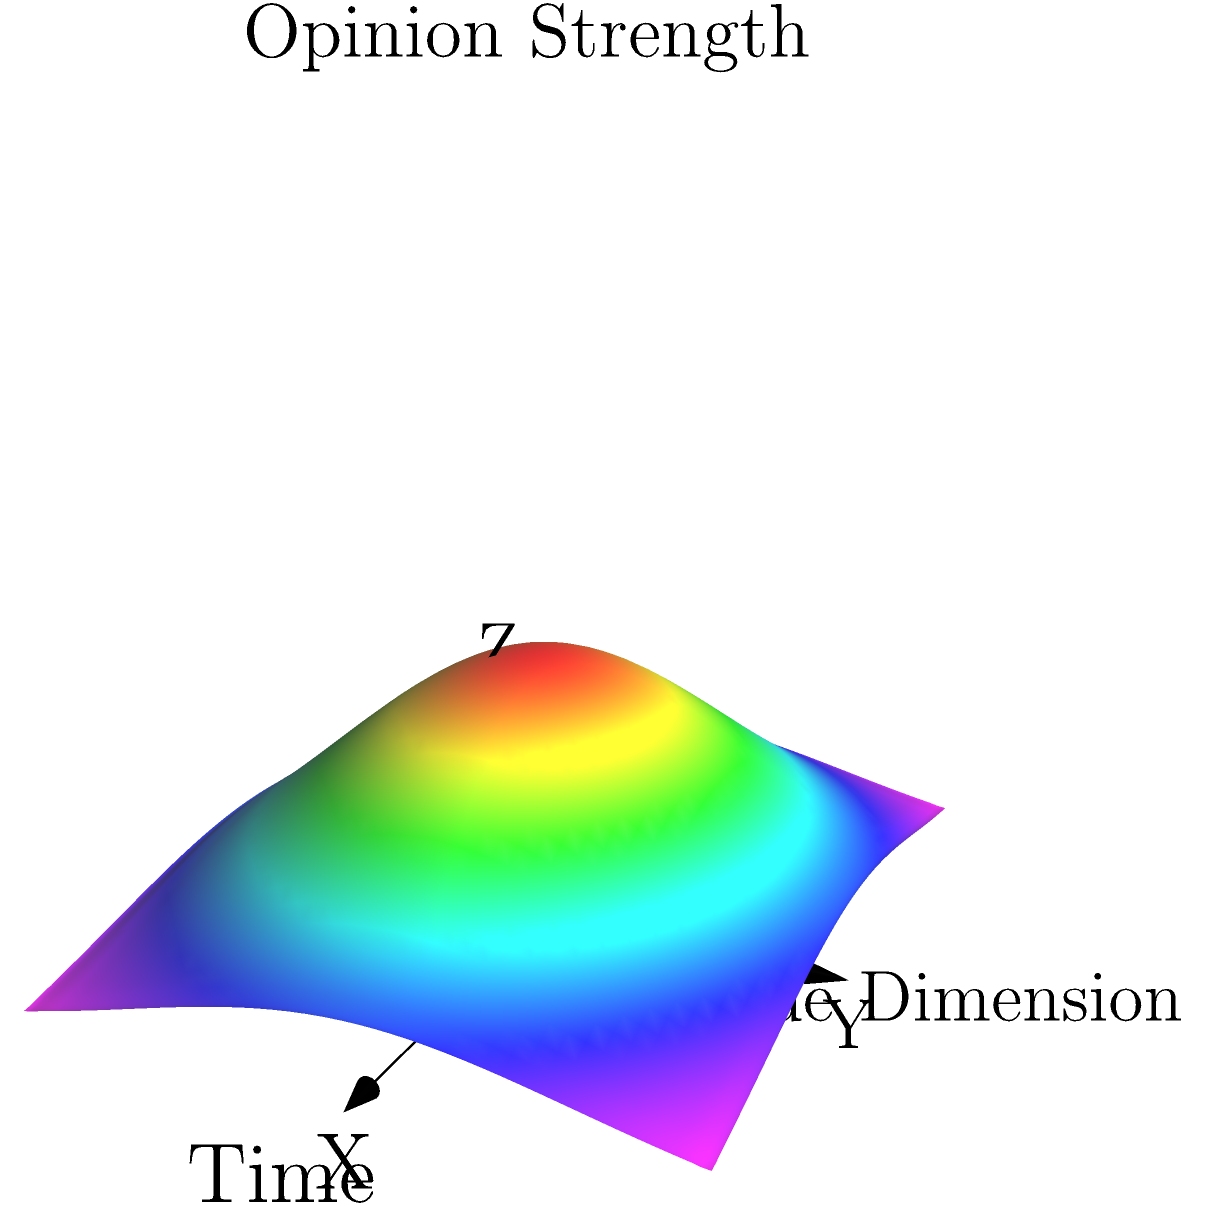Consider the three-dimensional representation of public opinion shifts over time shown in the figure. The X-axis represents time, the Y-axis represents different issue dimensions, and the Z-axis represents the strength of public opinion. The surface shows a Gaussian-like distribution that narrows and increases in height over time. What topological property does this surface exhibit, and how might it relate to the concentration of public opinion during a specific period of the Cold War? To answer this question, let's analyze the surface and its topological properties step-by-step:

1. Surface shape: The surface shows a Gaussian-like distribution in the XY plane, with a peak in the center.

2. Time evolution: As we move along the X-axis (time), the surface becomes narrower and taller.

3. Topological property: This surface exhibits a property called "homotopy". The surface at any given time slice (Y-Z plane) is homotopic to every other time slice, meaning it can be continuously deformed from one shape to another without tearing or gluing.

4. Interpretation in context:
   a) The narrowing of the surface over time represents a concentration of public opinion.
   b) The increasing height indicates stronger overall opinions.
   c) The maintenance of the basic shape (homotopy) suggests a consistent underlying structure of public opinion.

5. Relation to the Cold War:
   This topological representation could model the concentration of public opinion during a specific Cold War event, such as the Cuban Missile Crisis. As the crisis unfolded:
   a) Public attention would focus on a narrower range of issues (narrowing surface).
   b) Opinions would likely become stronger (increasing height).
   c) The basic structure of opinion distribution would remain similar (homotopy).

6. Mathematical representation:
   The surface could be described by a function like:
   $$f(x,y,z) = A(x) \cdot e^{-\frac{y^2}{2\sigma(x)^2}}$$
   where $A(x)$ increases with $x$ (time) and $\sigma(x)$ decreases with $x$, representing the narrowing and heightening of the distribution.

This topological approach allows for a geometric understanding of how public opinion evolved during critical periods of the Cold War, highlighting the concentration of attention and intensification of views while maintaining a consistent underlying structure.
Answer: Homotopy, representing concentration and intensification of public opinion while maintaining consistent structure. 